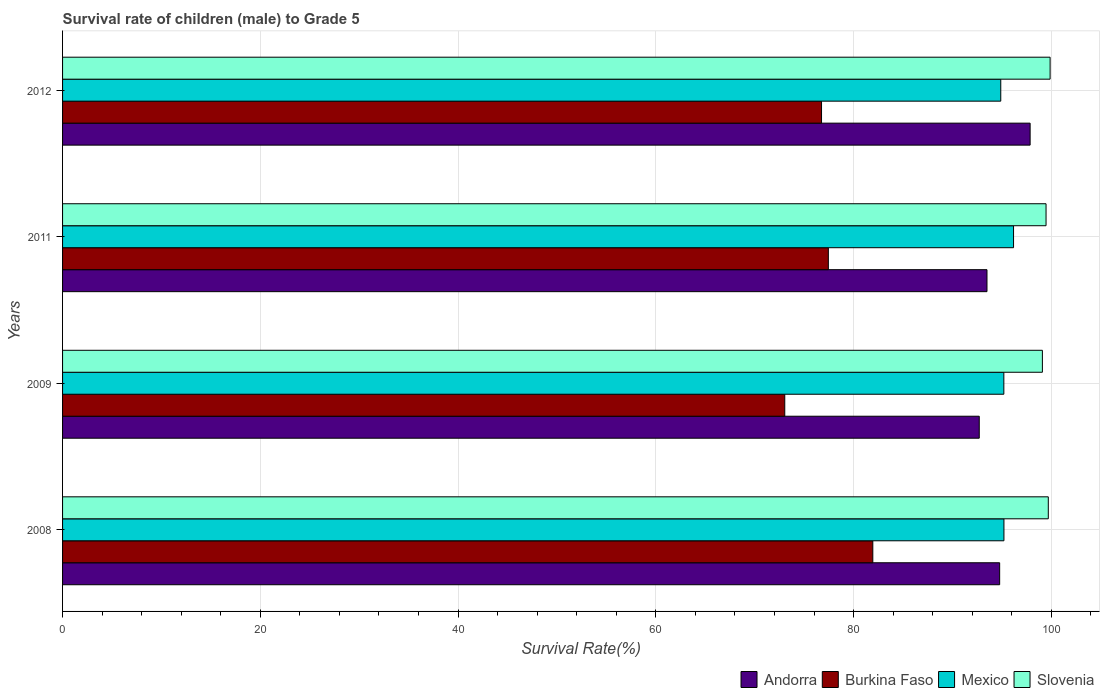How many different coloured bars are there?
Ensure brevity in your answer.  4. How many groups of bars are there?
Ensure brevity in your answer.  4. Are the number of bars per tick equal to the number of legend labels?
Ensure brevity in your answer.  Yes. Are the number of bars on each tick of the Y-axis equal?
Offer a terse response. Yes. What is the label of the 1st group of bars from the top?
Offer a terse response. 2012. What is the survival rate of male children to grade 5 in Andorra in 2012?
Your answer should be compact. 97.86. Across all years, what is the maximum survival rate of male children to grade 5 in Burkina Faso?
Keep it short and to the point. 81.95. Across all years, what is the minimum survival rate of male children to grade 5 in Andorra?
Provide a succinct answer. 92.71. In which year was the survival rate of male children to grade 5 in Mexico minimum?
Keep it short and to the point. 2012. What is the total survival rate of male children to grade 5 in Slovenia in the graph?
Keep it short and to the point. 398.13. What is the difference between the survival rate of male children to grade 5 in Burkina Faso in 2009 and that in 2012?
Your response must be concise. -3.72. What is the difference between the survival rate of male children to grade 5 in Mexico in 2011 and the survival rate of male children to grade 5 in Burkina Faso in 2012?
Provide a succinct answer. 19.42. What is the average survival rate of male children to grade 5 in Andorra per year?
Give a very brief answer. 94.71. In the year 2012, what is the difference between the survival rate of male children to grade 5 in Slovenia and survival rate of male children to grade 5 in Andorra?
Ensure brevity in your answer.  2.02. What is the ratio of the survival rate of male children to grade 5 in Andorra in 2008 to that in 2012?
Keep it short and to the point. 0.97. Is the survival rate of male children to grade 5 in Mexico in 2008 less than that in 2011?
Provide a short and direct response. Yes. What is the difference between the highest and the second highest survival rate of male children to grade 5 in Slovenia?
Offer a very short reply. 0.18. What is the difference between the highest and the lowest survival rate of male children to grade 5 in Mexico?
Ensure brevity in your answer.  1.29. Is the sum of the survival rate of male children to grade 5 in Slovenia in 2008 and 2009 greater than the maximum survival rate of male children to grade 5 in Andorra across all years?
Your response must be concise. Yes. Is it the case that in every year, the sum of the survival rate of male children to grade 5 in Andorra and survival rate of male children to grade 5 in Burkina Faso is greater than the sum of survival rate of male children to grade 5 in Mexico and survival rate of male children to grade 5 in Slovenia?
Provide a succinct answer. No. What does the 1st bar from the top in 2008 represents?
Ensure brevity in your answer.  Slovenia. What does the 2nd bar from the bottom in 2011 represents?
Your answer should be very brief. Burkina Faso. Is it the case that in every year, the sum of the survival rate of male children to grade 5 in Burkina Faso and survival rate of male children to grade 5 in Andorra is greater than the survival rate of male children to grade 5 in Slovenia?
Provide a succinct answer. Yes. How many years are there in the graph?
Keep it short and to the point. 4. What is the difference between two consecutive major ticks on the X-axis?
Give a very brief answer. 20. How many legend labels are there?
Your answer should be compact. 4. How are the legend labels stacked?
Offer a terse response. Horizontal. What is the title of the graph?
Ensure brevity in your answer.  Survival rate of children (male) to Grade 5. Does "Monaco" appear as one of the legend labels in the graph?
Provide a succinct answer. No. What is the label or title of the X-axis?
Your answer should be very brief. Survival Rate(%). What is the Survival Rate(%) of Andorra in 2008?
Your answer should be compact. 94.77. What is the Survival Rate(%) in Burkina Faso in 2008?
Offer a very short reply. 81.95. What is the Survival Rate(%) of Mexico in 2008?
Make the answer very short. 95.21. What is the Survival Rate(%) in Slovenia in 2008?
Keep it short and to the point. 99.69. What is the Survival Rate(%) of Andorra in 2009?
Offer a terse response. 92.71. What is the Survival Rate(%) in Burkina Faso in 2009?
Make the answer very short. 73.04. What is the Survival Rate(%) of Mexico in 2009?
Your response must be concise. 95.2. What is the Survival Rate(%) of Slovenia in 2009?
Your response must be concise. 99.1. What is the Survival Rate(%) of Andorra in 2011?
Make the answer very short. 93.49. What is the Survival Rate(%) of Burkina Faso in 2011?
Offer a very short reply. 77.45. What is the Survival Rate(%) in Mexico in 2011?
Make the answer very short. 96.18. What is the Survival Rate(%) in Slovenia in 2011?
Give a very brief answer. 99.47. What is the Survival Rate(%) of Andorra in 2012?
Ensure brevity in your answer.  97.86. What is the Survival Rate(%) in Burkina Faso in 2012?
Your answer should be compact. 76.76. What is the Survival Rate(%) in Mexico in 2012?
Offer a very short reply. 94.89. What is the Survival Rate(%) of Slovenia in 2012?
Your answer should be compact. 99.88. Across all years, what is the maximum Survival Rate(%) in Andorra?
Make the answer very short. 97.86. Across all years, what is the maximum Survival Rate(%) in Burkina Faso?
Ensure brevity in your answer.  81.95. Across all years, what is the maximum Survival Rate(%) in Mexico?
Provide a succinct answer. 96.18. Across all years, what is the maximum Survival Rate(%) in Slovenia?
Your answer should be very brief. 99.88. Across all years, what is the minimum Survival Rate(%) in Andorra?
Your answer should be very brief. 92.71. Across all years, what is the minimum Survival Rate(%) of Burkina Faso?
Provide a short and direct response. 73.04. Across all years, what is the minimum Survival Rate(%) in Mexico?
Your answer should be compact. 94.89. Across all years, what is the minimum Survival Rate(%) of Slovenia?
Your response must be concise. 99.1. What is the total Survival Rate(%) in Andorra in the graph?
Offer a very short reply. 378.83. What is the total Survival Rate(%) in Burkina Faso in the graph?
Your answer should be very brief. 309.19. What is the total Survival Rate(%) of Mexico in the graph?
Your answer should be very brief. 381.47. What is the total Survival Rate(%) in Slovenia in the graph?
Provide a succinct answer. 398.13. What is the difference between the Survival Rate(%) in Andorra in 2008 and that in 2009?
Make the answer very short. 2.06. What is the difference between the Survival Rate(%) in Burkina Faso in 2008 and that in 2009?
Give a very brief answer. 8.91. What is the difference between the Survival Rate(%) in Mexico in 2008 and that in 2009?
Your answer should be compact. 0.01. What is the difference between the Survival Rate(%) in Slovenia in 2008 and that in 2009?
Provide a succinct answer. 0.6. What is the difference between the Survival Rate(%) of Andorra in 2008 and that in 2011?
Ensure brevity in your answer.  1.28. What is the difference between the Survival Rate(%) in Burkina Faso in 2008 and that in 2011?
Give a very brief answer. 4.5. What is the difference between the Survival Rate(%) of Mexico in 2008 and that in 2011?
Offer a very short reply. -0.97. What is the difference between the Survival Rate(%) of Slovenia in 2008 and that in 2011?
Make the answer very short. 0.23. What is the difference between the Survival Rate(%) in Andorra in 2008 and that in 2012?
Make the answer very short. -3.08. What is the difference between the Survival Rate(%) of Burkina Faso in 2008 and that in 2012?
Keep it short and to the point. 5.19. What is the difference between the Survival Rate(%) of Mexico in 2008 and that in 2012?
Ensure brevity in your answer.  0.32. What is the difference between the Survival Rate(%) in Slovenia in 2008 and that in 2012?
Provide a succinct answer. -0.18. What is the difference between the Survival Rate(%) of Andorra in 2009 and that in 2011?
Ensure brevity in your answer.  -0.78. What is the difference between the Survival Rate(%) of Burkina Faso in 2009 and that in 2011?
Your answer should be very brief. -4.41. What is the difference between the Survival Rate(%) of Mexico in 2009 and that in 2011?
Your answer should be very brief. -0.98. What is the difference between the Survival Rate(%) in Slovenia in 2009 and that in 2011?
Offer a terse response. -0.37. What is the difference between the Survival Rate(%) of Andorra in 2009 and that in 2012?
Give a very brief answer. -5.14. What is the difference between the Survival Rate(%) in Burkina Faso in 2009 and that in 2012?
Offer a terse response. -3.72. What is the difference between the Survival Rate(%) of Mexico in 2009 and that in 2012?
Your answer should be very brief. 0.31. What is the difference between the Survival Rate(%) of Slovenia in 2009 and that in 2012?
Your response must be concise. -0.78. What is the difference between the Survival Rate(%) in Andorra in 2011 and that in 2012?
Your response must be concise. -4.36. What is the difference between the Survival Rate(%) in Burkina Faso in 2011 and that in 2012?
Provide a succinct answer. 0.69. What is the difference between the Survival Rate(%) of Mexico in 2011 and that in 2012?
Your answer should be compact. 1.29. What is the difference between the Survival Rate(%) in Slovenia in 2011 and that in 2012?
Your answer should be very brief. -0.41. What is the difference between the Survival Rate(%) of Andorra in 2008 and the Survival Rate(%) of Burkina Faso in 2009?
Provide a short and direct response. 21.73. What is the difference between the Survival Rate(%) in Andorra in 2008 and the Survival Rate(%) in Mexico in 2009?
Keep it short and to the point. -0.42. What is the difference between the Survival Rate(%) of Andorra in 2008 and the Survival Rate(%) of Slovenia in 2009?
Give a very brief answer. -4.32. What is the difference between the Survival Rate(%) in Burkina Faso in 2008 and the Survival Rate(%) in Mexico in 2009?
Make the answer very short. -13.25. What is the difference between the Survival Rate(%) in Burkina Faso in 2008 and the Survival Rate(%) in Slovenia in 2009?
Make the answer very short. -17.15. What is the difference between the Survival Rate(%) of Mexico in 2008 and the Survival Rate(%) of Slovenia in 2009?
Give a very brief answer. -3.89. What is the difference between the Survival Rate(%) in Andorra in 2008 and the Survival Rate(%) in Burkina Faso in 2011?
Ensure brevity in your answer.  17.33. What is the difference between the Survival Rate(%) in Andorra in 2008 and the Survival Rate(%) in Mexico in 2011?
Make the answer very short. -1.4. What is the difference between the Survival Rate(%) in Andorra in 2008 and the Survival Rate(%) in Slovenia in 2011?
Keep it short and to the point. -4.69. What is the difference between the Survival Rate(%) in Burkina Faso in 2008 and the Survival Rate(%) in Mexico in 2011?
Make the answer very short. -14.23. What is the difference between the Survival Rate(%) in Burkina Faso in 2008 and the Survival Rate(%) in Slovenia in 2011?
Provide a short and direct response. -17.52. What is the difference between the Survival Rate(%) in Mexico in 2008 and the Survival Rate(%) in Slovenia in 2011?
Provide a short and direct response. -4.26. What is the difference between the Survival Rate(%) of Andorra in 2008 and the Survival Rate(%) of Burkina Faso in 2012?
Provide a short and direct response. 18.02. What is the difference between the Survival Rate(%) of Andorra in 2008 and the Survival Rate(%) of Mexico in 2012?
Ensure brevity in your answer.  -0.11. What is the difference between the Survival Rate(%) of Andorra in 2008 and the Survival Rate(%) of Slovenia in 2012?
Ensure brevity in your answer.  -5.1. What is the difference between the Survival Rate(%) of Burkina Faso in 2008 and the Survival Rate(%) of Mexico in 2012?
Provide a short and direct response. -12.94. What is the difference between the Survival Rate(%) in Burkina Faso in 2008 and the Survival Rate(%) in Slovenia in 2012?
Make the answer very short. -17.93. What is the difference between the Survival Rate(%) of Mexico in 2008 and the Survival Rate(%) of Slovenia in 2012?
Give a very brief answer. -4.67. What is the difference between the Survival Rate(%) of Andorra in 2009 and the Survival Rate(%) of Burkina Faso in 2011?
Your answer should be very brief. 15.26. What is the difference between the Survival Rate(%) in Andorra in 2009 and the Survival Rate(%) in Mexico in 2011?
Provide a short and direct response. -3.47. What is the difference between the Survival Rate(%) in Andorra in 2009 and the Survival Rate(%) in Slovenia in 2011?
Give a very brief answer. -6.76. What is the difference between the Survival Rate(%) in Burkina Faso in 2009 and the Survival Rate(%) in Mexico in 2011?
Provide a succinct answer. -23.14. What is the difference between the Survival Rate(%) of Burkina Faso in 2009 and the Survival Rate(%) of Slovenia in 2011?
Ensure brevity in your answer.  -26.43. What is the difference between the Survival Rate(%) of Mexico in 2009 and the Survival Rate(%) of Slovenia in 2011?
Give a very brief answer. -4.27. What is the difference between the Survival Rate(%) of Andorra in 2009 and the Survival Rate(%) of Burkina Faso in 2012?
Your answer should be very brief. 15.95. What is the difference between the Survival Rate(%) in Andorra in 2009 and the Survival Rate(%) in Mexico in 2012?
Make the answer very short. -2.18. What is the difference between the Survival Rate(%) in Andorra in 2009 and the Survival Rate(%) in Slovenia in 2012?
Offer a terse response. -7.17. What is the difference between the Survival Rate(%) of Burkina Faso in 2009 and the Survival Rate(%) of Mexico in 2012?
Keep it short and to the point. -21.85. What is the difference between the Survival Rate(%) of Burkina Faso in 2009 and the Survival Rate(%) of Slovenia in 2012?
Give a very brief answer. -26.84. What is the difference between the Survival Rate(%) of Mexico in 2009 and the Survival Rate(%) of Slovenia in 2012?
Your answer should be compact. -4.68. What is the difference between the Survival Rate(%) of Andorra in 2011 and the Survival Rate(%) of Burkina Faso in 2012?
Your response must be concise. 16.73. What is the difference between the Survival Rate(%) in Andorra in 2011 and the Survival Rate(%) in Mexico in 2012?
Offer a terse response. -1.39. What is the difference between the Survival Rate(%) in Andorra in 2011 and the Survival Rate(%) in Slovenia in 2012?
Provide a succinct answer. -6.39. What is the difference between the Survival Rate(%) in Burkina Faso in 2011 and the Survival Rate(%) in Mexico in 2012?
Your answer should be very brief. -17.44. What is the difference between the Survival Rate(%) in Burkina Faso in 2011 and the Survival Rate(%) in Slovenia in 2012?
Make the answer very short. -22.43. What is the difference between the Survival Rate(%) in Mexico in 2011 and the Survival Rate(%) in Slovenia in 2012?
Provide a succinct answer. -3.7. What is the average Survival Rate(%) of Andorra per year?
Offer a terse response. 94.71. What is the average Survival Rate(%) in Burkina Faso per year?
Ensure brevity in your answer.  77.3. What is the average Survival Rate(%) in Mexico per year?
Give a very brief answer. 95.37. What is the average Survival Rate(%) in Slovenia per year?
Your answer should be compact. 99.53. In the year 2008, what is the difference between the Survival Rate(%) of Andorra and Survival Rate(%) of Burkina Faso?
Offer a very short reply. 12.83. In the year 2008, what is the difference between the Survival Rate(%) of Andorra and Survival Rate(%) of Mexico?
Provide a succinct answer. -0.43. In the year 2008, what is the difference between the Survival Rate(%) of Andorra and Survival Rate(%) of Slovenia?
Offer a terse response. -4.92. In the year 2008, what is the difference between the Survival Rate(%) of Burkina Faso and Survival Rate(%) of Mexico?
Offer a terse response. -13.26. In the year 2008, what is the difference between the Survival Rate(%) in Burkina Faso and Survival Rate(%) in Slovenia?
Provide a short and direct response. -17.75. In the year 2008, what is the difference between the Survival Rate(%) of Mexico and Survival Rate(%) of Slovenia?
Your response must be concise. -4.49. In the year 2009, what is the difference between the Survival Rate(%) in Andorra and Survival Rate(%) in Burkina Faso?
Your response must be concise. 19.67. In the year 2009, what is the difference between the Survival Rate(%) of Andorra and Survival Rate(%) of Mexico?
Offer a terse response. -2.49. In the year 2009, what is the difference between the Survival Rate(%) of Andorra and Survival Rate(%) of Slovenia?
Make the answer very short. -6.39. In the year 2009, what is the difference between the Survival Rate(%) in Burkina Faso and Survival Rate(%) in Mexico?
Your answer should be very brief. -22.16. In the year 2009, what is the difference between the Survival Rate(%) of Burkina Faso and Survival Rate(%) of Slovenia?
Your answer should be compact. -26.06. In the year 2009, what is the difference between the Survival Rate(%) in Mexico and Survival Rate(%) in Slovenia?
Ensure brevity in your answer.  -3.9. In the year 2011, what is the difference between the Survival Rate(%) of Andorra and Survival Rate(%) of Burkina Faso?
Provide a short and direct response. 16.04. In the year 2011, what is the difference between the Survival Rate(%) in Andorra and Survival Rate(%) in Mexico?
Your answer should be compact. -2.69. In the year 2011, what is the difference between the Survival Rate(%) of Andorra and Survival Rate(%) of Slovenia?
Your response must be concise. -5.97. In the year 2011, what is the difference between the Survival Rate(%) of Burkina Faso and Survival Rate(%) of Mexico?
Offer a very short reply. -18.73. In the year 2011, what is the difference between the Survival Rate(%) of Burkina Faso and Survival Rate(%) of Slovenia?
Provide a short and direct response. -22.02. In the year 2011, what is the difference between the Survival Rate(%) of Mexico and Survival Rate(%) of Slovenia?
Keep it short and to the point. -3.29. In the year 2012, what is the difference between the Survival Rate(%) of Andorra and Survival Rate(%) of Burkina Faso?
Make the answer very short. 21.1. In the year 2012, what is the difference between the Survival Rate(%) of Andorra and Survival Rate(%) of Mexico?
Keep it short and to the point. 2.97. In the year 2012, what is the difference between the Survival Rate(%) of Andorra and Survival Rate(%) of Slovenia?
Provide a short and direct response. -2.02. In the year 2012, what is the difference between the Survival Rate(%) in Burkina Faso and Survival Rate(%) in Mexico?
Offer a terse response. -18.13. In the year 2012, what is the difference between the Survival Rate(%) in Burkina Faso and Survival Rate(%) in Slovenia?
Ensure brevity in your answer.  -23.12. In the year 2012, what is the difference between the Survival Rate(%) in Mexico and Survival Rate(%) in Slovenia?
Provide a short and direct response. -4.99. What is the ratio of the Survival Rate(%) in Andorra in 2008 to that in 2009?
Offer a very short reply. 1.02. What is the ratio of the Survival Rate(%) in Burkina Faso in 2008 to that in 2009?
Your answer should be very brief. 1.12. What is the ratio of the Survival Rate(%) of Mexico in 2008 to that in 2009?
Your answer should be compact. 1. What is the ratio of the Survival Rate(%) of Slovenia in 2008 to that in 2009?
Give a very brief answer. 1.01. What is the ratio of the Survival Rate(%) of Andorra in 2008 to that in 2011?
Your answer should be very brief. 1.01. What is the ratio of the Survival Rate(%) in Burkina Faso in 2008 to that in 2011?
Ensure brevity in your answer.  1.06. What is the ratio of the Survival Rate(%) in Andorra in 2008 to that in 2012?
Your answer should be compact. 0.97. What is the ratio of the Survival Rate(%) in Burkina Faso in 2008 to that in 2012?
Give a very brief answer. 1.07. What is the ratio of the Survival Rate(%) of Andorra in 2009 to that in 2011?
Your answer should be very brief. 0.99. What is the ratio of the Survival Rate(%) of Burkina Faso in 2009 to that in 2011?
Provide a succinct answer. 0.94. What is the ratio of the Survival Rate(%) in Andorra in 2009 to that in 2012?
Your answer should be compact. 0.95. What is the ratio of the Survival Rate(%) in Burkina Faso in 2009 to that in 2012?
Your answer should be very brief. 0.95. What is the ratio of the Survival Rate(%) in Mexico in 2009 to that in 2012?
Your response must be concise. 1. What is the ratio of the Survival Rate(%) of Andorra in 2011 to that in 2012?
Provide a short and direct response. 0.96. What is the ratio of the Survival Rate(%) in Mexico in 2011 to that in 2012?
Your answer should be very brief. 1.01. What is the difference between the highest and the second highest Survival Rate(%) of Andorra?
Provide a succinct answer. 3.08. What is the difference between the highest and the second highest Survival Rate(%) of Burkina Faso?
Offer a very short reply. 4.5. What is the difference between the highest and the second highest Survival Rate(%) in Mexico?
Ensure brevity in your answer.  0.97. What is the difference between the highest and the second highest Survival Rate(%) in Slovenia?
Your response must be concise. 0.18. What is the difference between the highest and the lowest Survival Rate(%) in Andorra?
Your answer should be very brief. 5.14. What is the difference between the highest and the lowest Survival Rate(%) in Burkina Faso?
Keep it short and to the point. 8.91. What is the difference between the highest and the lowest Survival Rate(%) of Mexico?
Give a very brief answer. 1.29. What is the difference between the highest and the lowest Survival Rate(%) in Slovenia?
Offer a terse response. 0.78. 